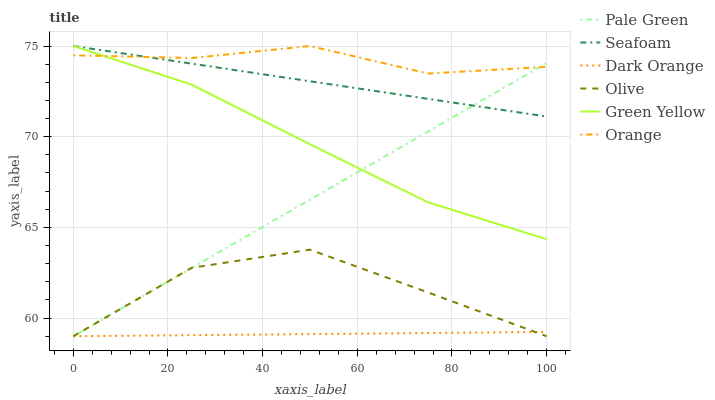Does Dark Orange have the minimum area under the curve?
Answer yes or no. Yes. Does Orange have the maximum area under the curve?
Answer yes or no. Yes. Does Seafoam have the minimum area under the curve?
Answer yes or no. No. Does Seafoam have the maximum area under the curve?
Answer yes or no. No. Is Dark Orange the smoothest?
Answer yes or no. Yes. Is Olive the roughest?
Answer yes or no. Yes. Is Seafoam the smoothest?
Answer yes or no. No. Is Seafoam the roughest?
Answer yes or no. No. Does Dark Orange have the lowest value?
Answer yes or no. Yes. Does Seafoam have the lowest value?
Answer yes or no. No. Does Green Yellow have the highest value?
Answer yes or no. Yes. Does Pale Green have the highest value?
Answer yes or no. No. Is Olive less than Seafoam?
Answer yes or no. Yes. Is Seafoam greater than Dark Orange?
Answer yes or no. Yes. Does Dark Orange intersect Olive?
Answer yes or no. Yes. Is Dark Orange less than Olive?
Answer yes or no. No. Is Dark Orange greater than Olive?
Answer yes or no. No. Does Olive intersect Seafoam?
Answer yes or no. No. 